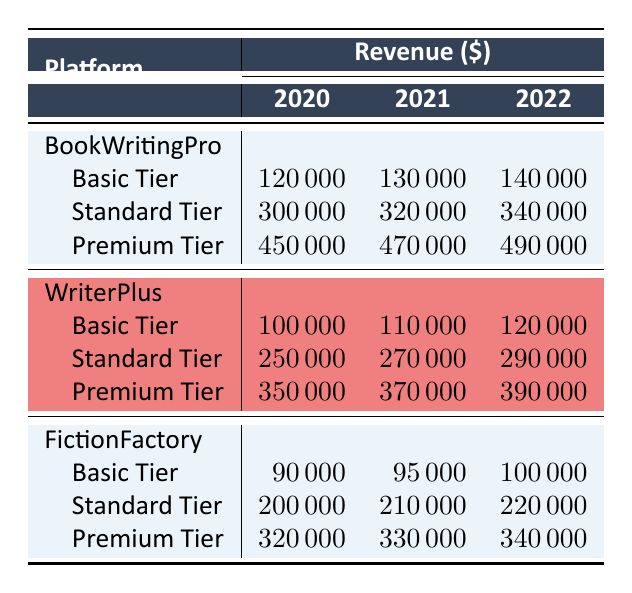What was the total revenue from all tiers on the BookWritingPro platform in 2020? To find the total revenue for BookWritingPro in 2020, we add the revenues of all tiers: Basic Tier (120000) + Standard Tier (300000) + Premium Tier (450000) = 870000.
Answer: 870000 Which platform had the highest Premium Tier revenue in 2021? We compare the Premium Tier revenues of all platforms in 2021: BookWritingPro (470000), WriterPlus (370000), and FictionFactory (330000). The highest value is 470000 from BookWritingPro.
Answer: BookWritingPro What is the difference in the Standard Tier revenue for WriterPlus between 2020 and 2022? The Standard Tier revenue for WriterPlus in 2020 is 250000 and in 2022 is 290000. The difference is 290000 - 250000 = 40000.
Answer: 40000 Was the revenue from the Basic Tier for FictionFactory consistent over the three years? The Basic Tier revenues for FictionFactory are: 90000 in 2020, 95000 in 2021, and 100000 in 2022. Since the revenue increased each year, we can say it was not consistent because it increased.
Answer: No What was the average revenue from the Premium Tier across all platforms in 2022? The Premium Tier revenues for all platforms in 2022 are: BookWritingPro (490000), WriterPlus (390000), and FictionFactory (340000). To find the average, we sum them: 490000 + 390000 + 340000 = 1220000, and then divide by 3 (the number of platforms) to get the average: 1220000 / 3 = 406666.67 (or rounded to 406667).
Answer: 406667 Which tier for WriterPlus saw the least growth in revenue from 2020 to 2021? The revenues for WriterPlus are: Basic Tier (100000 to 110000, growth of 10000), Standard Tier (250000 to 270000, growth of 20000), Premium Tier (350000 to 370000, growth of 20000). The Basic Tier had the least growth at 10000.
Answer: Basic Tier What was the total revenue for FictionFactory in 2021? To calculate the total revenue for FictionFactory in 2021, we add the revenues of all tiers: Basic Tier (95000) + Standard Tier (210000) + Premium Tier (330000) = 634000.
Answer: 634000 Was the Basic Tier revenue for BookWritingPro higher than that of WriterPlus in all three years? In 2020, BookWritingPro (120000) was higher than WriterPlus (100000). In 2021, BookWritingPro (130000) was higher than WriterPlus (110000). In 2022, BookWritingPro (140000) was higher than WriterPlus (120000). Therefore, it was higher in all years.
Answer: Yes 